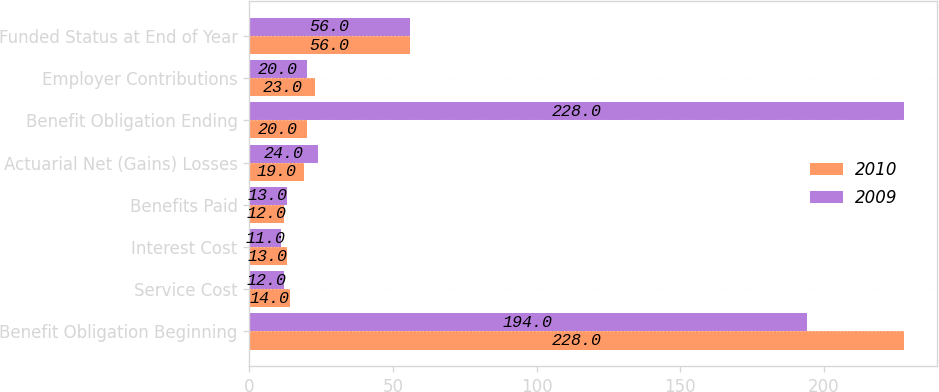<chart> <loc_0><loc_0><loc_500><loc_500><stacked_bar_chart><ecel><fcel>Benefit Obligation Beginning<fcel>Service Cost<fcel>Interest Cost<fcel>Benefits Paid<fcel>Actuarial Net (Gains) Losses<fcel>Benefit Obligation Ending<fcel>Employer Contributions<fcel>Funded Status at End of Year<nl><fcel>2010<fcel>228<fcel>14<fcel>13<fcel>12<fcel>19<fcel>20<fcel>23<fcel>56<nl><fcel>2009<fcel>194<fcel>12<fcel>11<fcel>13<fcel>24<fcel>228<fcel>20<fcel>56<nl></chart> 